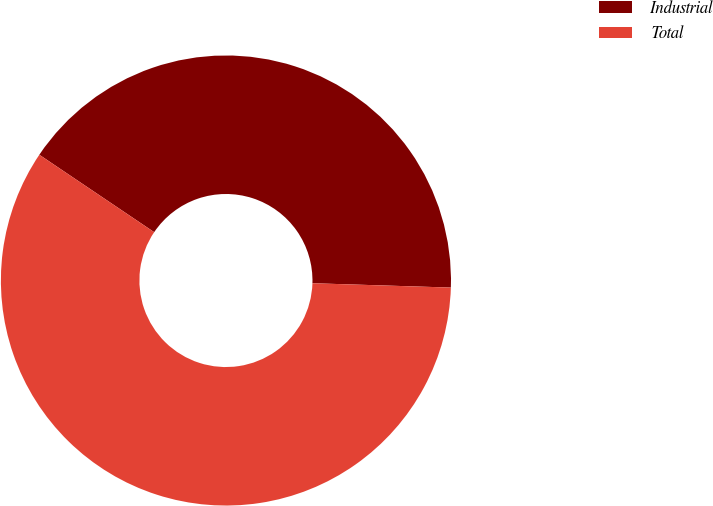Convert chart. <chart><loc_0><loc_0><loc_500><loc_500><pie_chart><fcel>Industrial<fcel>Total<nl><fcel>41.06%<fcel>58.94%<nl></chart> 